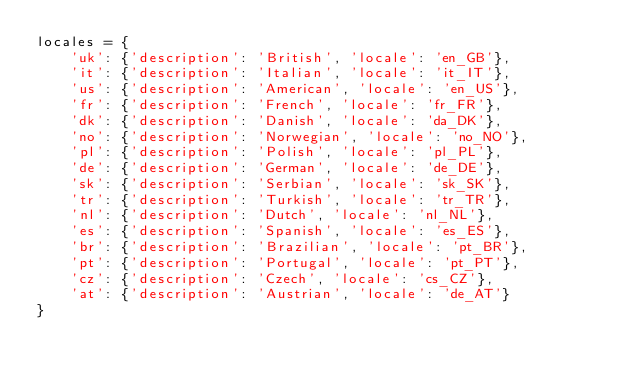Convert code to text. <code><loc_0><loc_0><loc_500><loc_500><_Python_>locales = {
    'uk': {'description': 'British', 'locale': 'en_GB'},
    'it': {'description': 'Italian', 'locale': 'it_IT'},
    'us': {'description': 'American', 'locale': 'en_US'},
    'fr': {'description': 'French', 'locale': 'fr_FR'},
    'dk': {'description': 'Danish', 'locale': 'da_DK'},
    'no': {'description': 'Norwegian', 'locale': 'no_NO'},
    'pl': {'description': 'Polish', 'locale': 'pl_PL'},
    'de': {'description': 'German', 'locale': 'de_DE'},
    'sk': {'description': 'Serbian', 'locale': 'sk_SK'},
    'tr': {'description': 'Turkish', 'locale': 'tr_TR'},
    'nl': {'description': 'Dutch', 'locale': 'nl_NL'},
    'es': {'description': 'Spanish', 'locale': 'es_ES'},
    'br': {'description': 'Brazilian', 'locale': 'pt_BR'},
    'pt': {'description': 'Portugal', 'locale': 'pt_PT'},
    'cz': {'description': 'Czech', 'locale': 'cs_CZ'},
    'at': {'description': 'Austrian', 'locale': 'de_AT'}
}
</code> 